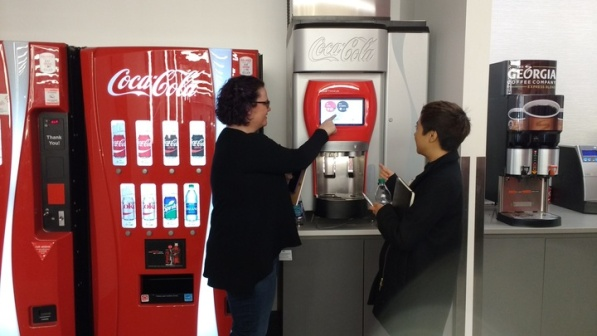What is this photo about'? In the image, a woman and a young boy are standing in a room with a gray floor and white walls. The woman is on the left side of the image, pointing at a red Coca Cola vending machine. This machine is equipped with a touch screen and a credit card reader, indicating it's a modern, digital model.

The young boy is on the right side of the image, looking at another red Coca Cola vending machine. This machine has a traditional button interface, suggesting it's an older model. Interestingly, this machine also carries a logo of the Georgia Coffee Company, hinting at the variety of beverages it might offer.

The two vending machines are the central objects in the room, standing side by side. Despite their shared brand, they represent different generations of technology, as evidenced by their distinct interfaces. The woman's interaction with the touch screen and the boy's attention towards the button interface further emphasize this contrast.

There's no discernible text in the image, and the room's other features are minimal, keeping the focus on the people and the vending machines. The overall scene captures a moment of interaction between humans and machines, highlighting the evolution of technology in everyday settings. 